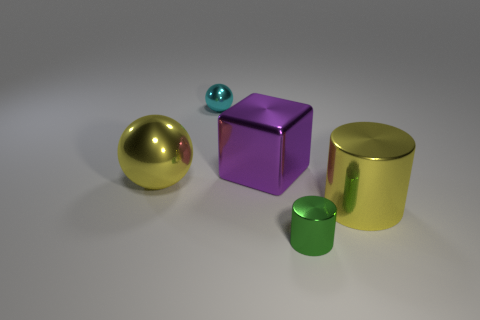Do the large cylinder and the large shiny ball have the same color?
Keep it short and to the point. Yes. There is a big object that is the same color as the large sphere; what is its shape?
Make the answer very short. Cylinder. What is the shape of the small metal object that is in front of the purple cube?
Your answer should be very brief. Cylinder. There is a yellow cylinder that is made of the same material as the block; what size is it?
Provide a succinct answer. Large. There is a object that is on the left side of the purple metal cube and in front of the tiny cyan metal thing; what is its shape?
Give a very brief answer. Sphere. There is a tiny object that is in front of the tiny shiny sphere; is its color the same as the large cube?
Provide a succinct answer. No. There is a large object that is left of the purple metallic thing; does it have the same shape as the tiny thing that is behind the yellow metallic cylinder?
Provide a succinct answer. Yes. How big is the metallic sphere that is behind the big purple shiny object?
Keep it short and to the point. Small. There is a sphere that is behind the yellow thing that is to the left of the yellow metal cylinder; how big is it?
Your response must be concise. Small. Is the number of yellow spheres greater than the number of blue rubber things?
Your answer should be very brief. Yes. 